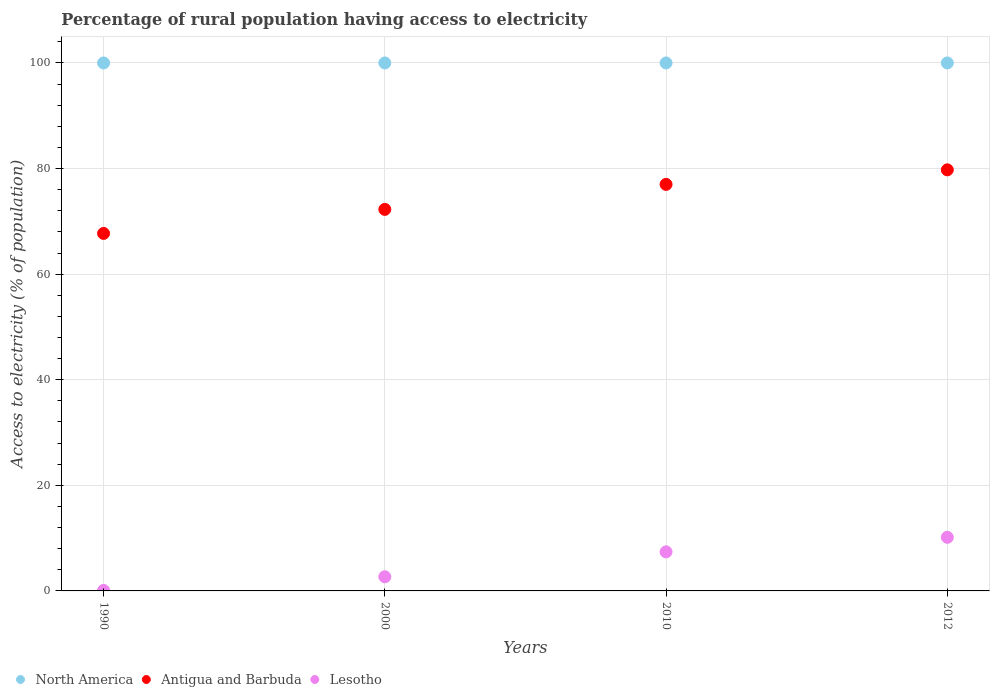How many different coloured dotlines are there?
Your answer should be very brief. 3. Is the number of dotlines equal to the number of legend labels?
Provide a succinct answer. Yes. What is the percentage of rural population having access to electricity in Lesotho in 2010?
Ensure brevity in your answer.  7.4. Across all years, what is the maximum percentage of rural population having access to electricity in North America?
Offer a very short reply. 100. Across all years, what is the minimum percentage of rural population having access to electricity in North America?
Offer a terse response. 100. What is the total percentage of rural population having access to electricity in Antigua and Barbuda in the graph?
Your response must be concise. 296.73. What is the difference between the percentage of rural population having access to electricity in Lesotho in 2000 and that in 2012?
Provide a short and direct response. -7.47. What is the difference between the percentage of rural population having access to electricity in Antigua and Barbuda in 2000 and the percentage of rural population having access to electricity in North America in 2012?
Provide a succinct answer. -27.73. What is the average percentage of rural population having access to electricity in Lesotho per year?
Offer a very short reply. 5.08. In the year 1990, what is the difference between the percentage of rural population having access to electricity in Lesotho and percentage of rural population having access to electricity in North America?
Make the answer very short. -99.9. Is the percentage of rural population having access to electricity in Lesotho in 1990 less than that in 2012?
Give a very brief answer. Yes. Is the difference between the percentage of rural population having access to electricity in Lesotho in 2000 and 2012 greater than the difference between the percentage of rural population having access to electricity in North America in 2000 and 2012?
Offer a terse response. No. What is the difference between the highest and the second highest percentage of rural population having access to electricity in Lesotho?
Offer a very short reply. 2.75. What is the difference between the highest and the lowest percentage of rural population having access to electricity in North America?
Your answer should be compact. 0. In how many years, is the percentage of rural population having access to electricity in Lesotho greater than the average percentage of rural population having access to electricity in Lesotho taken over all years?
Your answer should be compact. 2. Is the sum of the percentage of rural population having access to electricity in Lesotho in 2000 and 2012 greater than the maximum percentage of rural population having access to electricity in North America across all years?
Provide a short and direct response. No. Is it the case that in every year, the sum of the percentage of rural population having access to electricity in North America and percentage of rural population having access to electricity in Lesotho  is greater than the percentage of rural population having access to electricity in Antigua and Barbuda?
Offer a terse response. Yes. What is the difference between two consecutive major ticks on the Y-axis?
Offer a very short reply. 20. Are the values on the major ticks of Y-axis written in scientific E-notation?
Your response must be concise. No. Where does the legend appear in the graph?
Offer a terse response. Bottom left. What is the title of the graph?
Provide a succinct answer. Percentage of rural population having access to electricity. Does "High income: OECD" appear as one of the legend labels in the graph?
Ensure brevity in your answer.  No. What is the label or title of the Y-axis?
Keep it short and to the point. Access to electricity (% of population). What is the Access to electricity (% of population) of Antigua and Barbuda in 1990?
Provide a short and direct response. 67.71. What is the Access to electricity (% of population) of Lesotho in 1990?
Give a very brief answer. 0.1. What is the Access to electricity (% of population) in Antigua and Barbuda in 2000?
Provide a succinct answer. 72.27. What is the Access to electricity (% of population) in Lesotho in 2000?
Your answer should be very brief. 2.68. What is the Access to electricity (% of population) of North America in 2010?
Your response must be concise. 100. What is the Access to electricity (% of population) of Antigua and Barbuda in 2010?
Your answer should be very brief. 77. What is the Access to electricity (% of population) of North America in 2012?
Give a very brief answer. 100. What is the Access to electricity (% of population) in Antigua and Barbuda in 2012?
Offer a terse response. 79.75. What is the Access to electricity (% of population) in Lesotho in 2012?
Keep it short and to the point. 10.15. Across all years, what is the maximum Access to electricity (% of population) in North America?
Keep it short and to the point. 100. Across all years, what is the maximum Access to electricity (% of population) in Antigua and Barbuda?
Give a very brief answer. 79.75. Across all years, what is the maximum Access to electricity (% of population) of Lesotho?
Offer a terse response. 10.15. Across all years, what is the minimum Access to electricity (% of population) of Antigua and Barbuda?
Keep it short and to the point. 67.71. What is the total Access to electricity (% of population) of North America in the graph?
Your answer should be very brief. 400. What is the total Access to electricity (% of population) of Antigua and Barbuda in the graph?
Your answer should be compact. 296.73. What is the total Access to electricity (% of population) of Lesotho in the graph?
Ensure brevity in your answer.  20.34. What is the difference between the Access to electricity (% of population) of Antigua and Barbuda in 1990 and that in 2000?
Provide a short and direct response. -4.55. What is the difference between the Access to electricity (% of population) in Lesotho in 1990 and that in 2000?
Provide a short and direct response. -2.58. What is the difference between the Access to electricity (% of population) of North America in 1990 and that in 2010?
Offer a very short reply. 0. What is the difference between the Access to electricity (% of population) of Antigua and Barbuda in 1990 and that in 2010?
Provide a short and direct response. -9.29. What is the difference between the Access to electricity (% of population) in Lesotho in 1990 and that in 2010?
Your answer should be very brief. -7.3. What is the difference between the Access to electricity (% of population) of Antigua and Barbuda in 1990 and that in 2012?
Your answer should be very brief. -12.04. What is the difference between the Access to electricity (% of population) in Lesotho in 1990 and that in 2012?
Your answer should be very brief. -10.05. What is the difference between the Access to electricity (% of population) of Antigua and Barbuda in 2000 and that in 2010?
Make the answer very short. -4.74. What is the difference between the Access to electricity (% of population) of Lesotho in 2000 and that in 2010?
Give a very brief answer. -4.72. What is the difference between the Access to electricity (% of population) of Antigua and Barbuda in 2000 and that in 2012?
Provide a short and direct response. -7.49. What is the difference between the Access to electricity (% of population) in Lesotho in 2000 and that in 2012?
Your response must be concise. -7.47. What is the difference between the Access to electricity (% of population) of North America in 2010 and that in 2012?
Provide a short and direct response. 0. What is the difference between the Access to electricity (% of population) of Antigua and Barbuda in 2010 and that in 2012?
Offer a very short reply. -2.75. What is the difference between the Access to electricity (% of population) of Lesotho in 2010 and that in 2012?
Your response must be concise. -2.75. What is the difference between the Access to electricity (% of population) of North America in 1990 and the Access to electricity (% of population) of Antigua and Barbuda in 2000?
Your answer should be compact. 27.73. What is the difference between the Access to electricity (% of population) in North America in 1990 and the Access to electricity (% of population) in Lesotho in 2000?
Provide a short and direct response. 97.32. What is the difference between the Access to electricity (% of population) of Antigua and Barbuda in 1990 and the Access to electricity (% of population) of Lesotho in 2000?
Make the answer very short. 65.03. What is the difference between the Access to electricity (% of population) in North America in 1990 and the Access to electricity (% of population) in Lesotho in 2010?
Your answer should be very brief. 92.6. What is the difference between the Access to electricity (% of population) of Antigua and Barbuda in 1990 and the Access to electricity (% of population) of Lesotho in 2010?
Provide a succinct answer. 60.31. What is the difference between the Access to electricity (% of population) in North America in 1990 and the Access to electricity (% of population) in Antigua and Barbuda in 2012?
Make the answer very short. 20.25. What is the difference between the Access to electricity (% of population) of North America in 1990 and the Access to electricity (% of population) of Lesotho in 2012?
Provide a succinct answer. 89.85. What is the difference between the Access to electricity (% of population) of Antigua and Barbuda in 1990 and the Access to electricity (% of population) of Lesotho in 2012?
Provide a short and direct response. 57.56. What is the difference between the Access to electricity (% of population) of North America in 2000 and the Access to electricity (% of population) of Antigua and Barbuda in 2010?
Ensure brevity in your answer.  23. What is the difference between the Access to electricity (% of population) of North America in 2000 and the Access to electricity (% of population) of Lesotho in 2010?
Ensure brevity in your answer.  92.6. What is the difference between the Access to electricity (% of population) of Antigua and Barbuda in 2000 and the Access to electricity (% of population) of Lesotho in 2010?
Provide a short and direct response. 64.86. What is the difference between the Access to electricity (% of population) in North America in 2000 and the Access to electricity (% of population) in Antigua and Barbuda in 2012?
Give a very brief answer. 20.25. What is the difference between the Access to electricity (% of population) of North America in 2000 and the Access to electricity (% of population) of Lesotho in 2012?
Your answer should be very brief. 89.85. What is the difference between the Access to electricity (% of population) in Antigua and Barbuda in 2000 and the Access to electricity (% of population) in Lesotho in 2012?
Make the answer very short. 62.11. What is the difference between the Access to electricity (% of population) of North America in 2010 and the Access to electricity (% of population) of Antigua and Barbuda in 2012?
Your response must be concise. 20.25. What is the difference between the Access to electricity (% of population) in North America in 2010 and the Access to electricity (% of population) in Lesotho in 2012?
Keep it short and to the point. 89.85. What is the difference between the Access to electricity (% of population) in Antigua and Barbuda in 2010 and the Access to electricity (% of population) in Lesotho in 2012?
Offer a terse response. 66.85. What is the average Access to electricity (% of population) of North America per year?
Provide a succinct answer. 100. What is the average Access to electricity (% of population) in Antigua and Barbuda per year?
Provide a succinct answer. 74.18. What is the average Access to electricity (% of population) in Lesotho per year?
Your response must be concise. 5.08. In the year 1990, what is the difference between the Access to electricity (% of population) in North America and Access to electricity (% of population) in Antigua and Barbuda?
Make the answer very short. 32.29. In the year 1990, what is the difference between the Access to electricity (% of population) of North America and Access to electricity (% of population) of Lesotho?
Give a very brief answer. 99.9. In the year 1990, what is the difference between the Access to electricity (% of population) in Antigua and Barbuda and Access to electricity (% of population) in Lesotho?
Provide a succinct answer. 67.61. In the year 2000, what is the difference between the Access to electricity (% of population) in North America and Access to electricity (% of population) in Antigua and Barbuda?
Give a very brief answer. 27.73. In the year 2000, what is the difference between the Access to electricity (% of population) of North America and Access to electricity (% of population) of Lesotho?
Your response must be concise. 97.32. In the year 2000, what is the difference between the Access to electricity (% of population) of Antigua and Barbuda and Access to electricity (% of population) of Lesotho?
Give a very brief answer. 69.58. In the year 2010, what is the difference between the Access to electricity (% of population) of North America and Access to electricity (% of population) of Antigua and Barbuda?
Give a very brief answer. 23. In the year 2010, what is the difference between the Access to electricity (% of population) in North America and Access to electricity (% of population) in Lesotho?
Your answer should be very brief. 92.6. In the year 2010, what is the difference between the Access to electricity (% of population) of Antigua and Barbuda and Access to electricity (% of population) of Lesotho?
Provide a succinct answer. 69.6. In the year 2012, what is the difference between the Access to electricity (% of population) in North America and Access to electricity (% of population) in Antigua and Barbuda?
Your answer should be very brief. 20.25. In the year 2012, what is the difference between the Access to electricity (% of population) in North America and Access to electricity (% of population) in Lesotho?
Your answer should be very brief. 89.85. In the year 2012, what is the difference between the Access to electricity (% of population) of Antigua and Barbuda and Access to electricity (% of population) of Lesotho?
Your response must be concise. 69.6. What is the ratio of the Access to electricity (% of population) of North America in 1990 to that in 2000?
Make the answer very short. 1. What is the ratio of the Access to electricity (% of population) in Antigua and Barbuda in 1990 to that in 2000?
Offer a very short reply. 0.94. What is the ratio of the Access to electricity (% of population) in Lesotho in 1990 to that in 2000?
Ensure brevity in your answer.  0.04. What is the ratio of the Access to electricity (% of population) in North America in 1990 to that in 2010?
Offer a terse response. 1. What is the ratio of the Access to electricity (% of population) in Antigua and Barbuda in 1990 to that in 2010?
Keep it short and to the point. 0.88. What is the ratio of the Access to electricity (% of population) of Lesotho in 1990 to that in 2010?
Ensure brevity in your answer.  0.01. What is the ratio of the Access to electricity (% of population) in North America in 1990 to that in 2012?
Offer a terse response. 1. What is the ratio of the Access to electricity (% of population) in Antigua and Barbuda in 1990 to that in 2012?
Give a very brief answer. 0.85. What is the ratio of the Access to electricity (% of population) in Lesotho in 1990 to that in 2012?
Your answer should be very brief. 0.01. What is the ratio of the Access to electricity (% of population) of Antigua and Barbuda in 2000 to that in 2010?
Your response must be concise. 0.94. What is the ratio of the Access to electricity (% of population) in Lesotho in 2000 to that in 2010?
Ensure brevity in your answer.  0.36. What is the ratio of the Access to electricity (% of population) in North America in 2000 to that in 2012?
Ensure brevity in your answer.  1. What is the ratio of the Access to electricity (% of population) of Antigua and Barbuda in 2000 to that in 2012?
Offer a terse response. 0.91. What is the ratio of the Access to electricity (% of population) of Lesotho in 2000 to that in 2012?
Your response must be concise. 0.26. What is the ratio of the Access to electricity (% of population) in Antigua and Barbuda in 2010 to that in 2012?
Provide a succinct answer. 0.97. What is the ratio of the Access to electricity (% of population) of Lesotho in 2010 to that in 2012?
Ensure brevity in your answer.  0.73. What is the difference between the highest and the second highest Access to electricity (% of population) of North America?
Make the answer very short. 0. What is the difference between the highest and the second highest Access to electricity (% of population) in Antigua and Barbuda?
Offer a terse response. 2.75. What is the difference between the highest and the second highest Access to electricity (% of population) in Lesotho?
Your answer should be compact. 2.75. What is the difference between the highest and the lowest Access to electricity (% of population) in North America?
Your answer should be compact. 0. What is the difference between the highest and the lowest Access to electricity (% of population) of Antigua and Barbuda?
Provide a succinct answer. 12.04. What is the difference between the highest and the lowest Access to electricity (% of population) of Lesotho?
Ensure brevity in your answer.  10.05. 